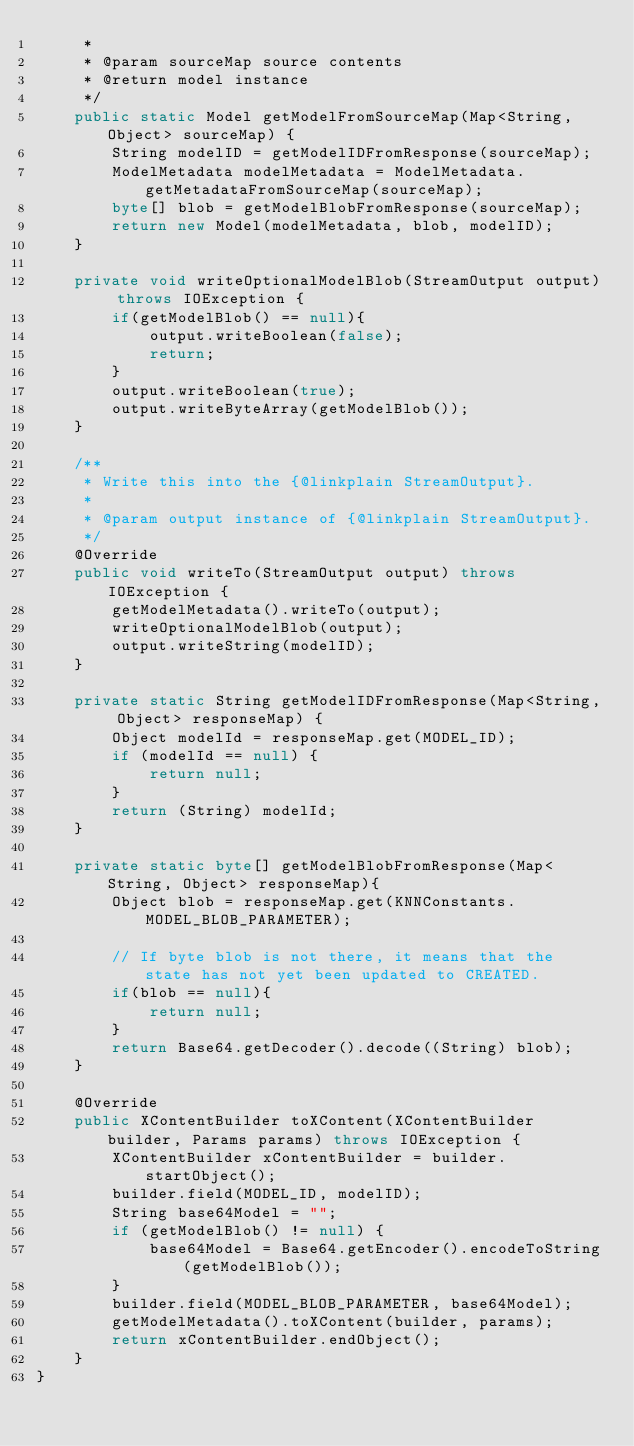Convert code to text. <code><loc_0><loc_0><loc_500><loc_500><_Java_>     *
     * @param sourceMap source contents
     * @return model instance
     */
    public static Model getModelFromSourceMap(Map<String, Object> sourceMap) {
        String modelID = getModelIDFromResponse(sourceMap);
        ModelMetadata modelMetadata = ModelMetadata.getMetadataFromSourceMap(sourceMap);
        byte[] blob = getModelBlobFromResponse(sourceMap);
        return new Model(modelMetadata, blob, modelID);
    }

    private void writeOptionalModelBlob(StreamOutput output) throws IOException {
        if(getModelBlob() == null){
            output.writeBoolean(false);
            return;
        }
        output.writeBoolean(true);
        output.writeByteArray(getModelBlob());
    }

    /**
     * Write this into the {@linkplain StreamOutput}.
     *
     * @param output instance of {@linkplain StreamOutput}.
     */
    @Override
    public void writeTo(StreamOutput output) throws IOException {
        getModelMetadata().writeTo(output);
        writeOptionalModelBlob(output);
        output.writeString(modelID);
    }

    private static String getModelIDFromResponse(Map<String, Object> responseMap) {
        Object modelId = responseMap.get(MODEL_ID);
        if (modelId == null) {
            return null;
        }
        return (String) modelId;
    }

    private static byte[] getModelBlobFromResponse(Map<String, Object> responseMap){
        Object blob = responseMap.get(KNNConstants.MODEL_BLOB_PARAMETER);

        // If byte blob is not there, it means that the state has not yet been updated to CREATED.
        if(blob == null){
            return null;
        }
        return Base64.getDecoder().decode((String) blob);
    }

    @Override
    public XContentBuilder toXContent(XContentBuilder builder, Params params) throws IOException {
        XContentBuilder xContentBuilder = builder.startObject();
        builder.field(MODEL_ID, modelID);
        String base64Model = "";
        if (getModelBlob() != null) {
            base64Model = Base64.getEncoder().encodeToString(getModelBlob());
        }
        builder.field(MODEL_BLOB_PARAMETER, base64Model);
        getModelMetadata().toXContent(builder, params);
        return xContentBuilder.endObject();
    }
}
</code> 